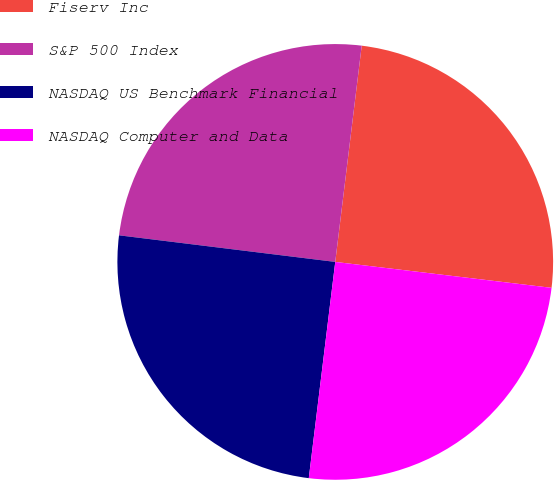Convert chart. <chart><loc_0><loc_0><loc_500><loc_500><pie_chart><fcel>Fiserv Inc<fcel>S&P 500 Index<fcel>NASDAQ US Benchmark Financial<fcel>NASDAQ Computer and Data<nl><fcel>24.96%<fcel>24.99%<fcel>25.01%<fcel>25.04%<nl></chart> 